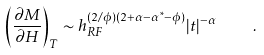Convert formula to latex. <formula><loc_0><loc_0><loc_500><loc_500>\left ( \frac { \partial M } { \partial H } \right ) _ { T } \sim h _ { R F } ^ { ( 2 / \phi ) ( 2 + \alpha - \alpha ^ { * } - \phi ) } | t | ^ { - \alpha } \quad .</formula> 